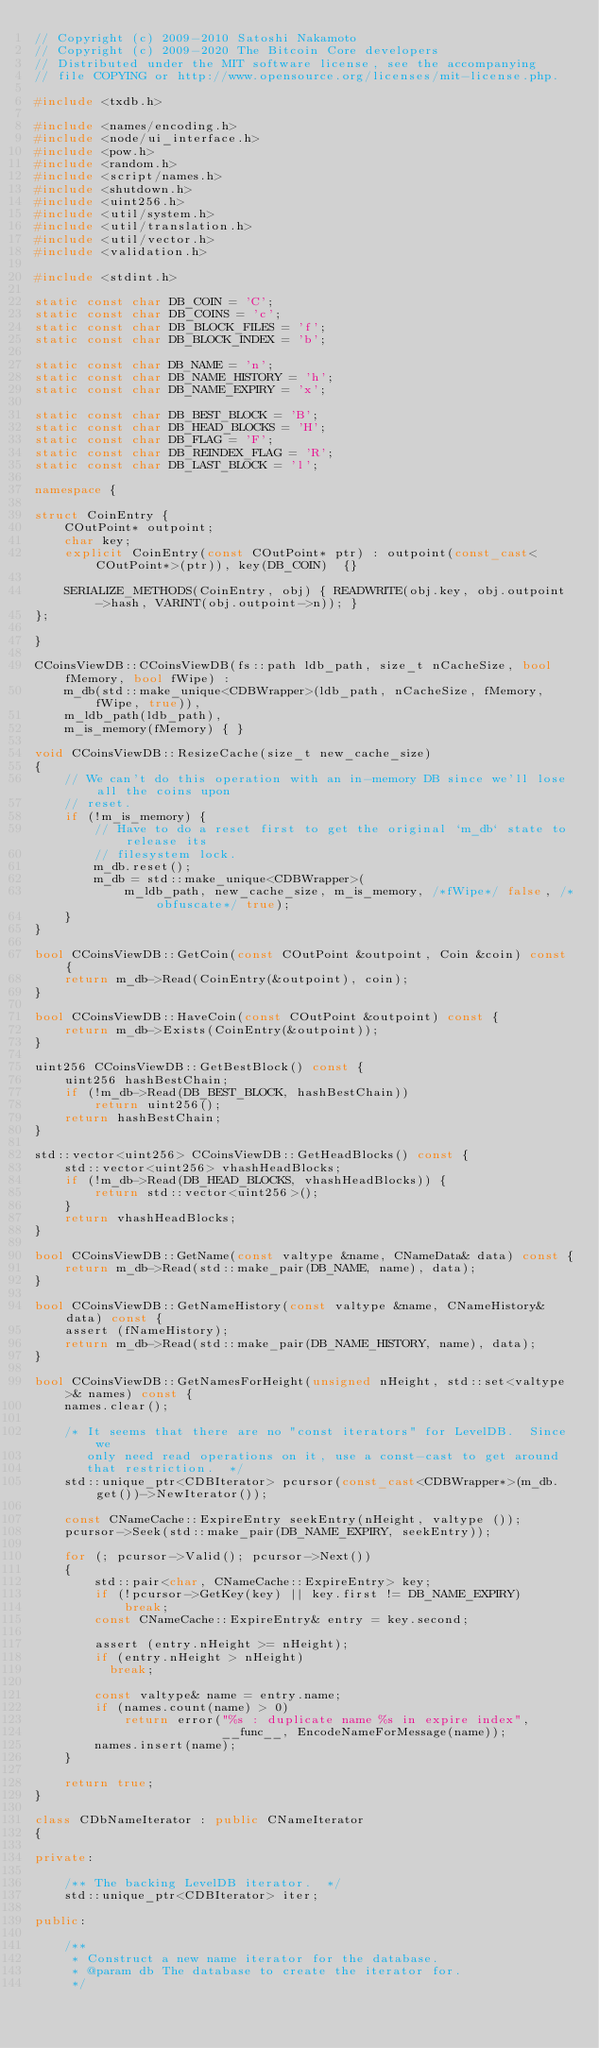Convert code to text. <code><loc_0><loc_0><loc_500><loc_500><_C++_>// Copyright (c) 2009-2010 Satoshi Nakamoto
// Copyright (c) 2009-2020 The Bitcoin Core developers
// Distributed under the MIT software license, see the accompanying
// file COPYING or http://www.opensource.org/licenses/mit-license.php.

#include <txdb.h>

#include <names/encoding.h>
#include <node/ui_interface.h>
#include <pow.h>
#include <random.h>
#include <script/names.h>
#include <shutdown.h>
#include <uint256.h>
#include <util/system.h>
#include <util/translation.h>
#include <util/vector.h>
#include <validation.h>

#include <stdint.h>

static const char DB_COIN = 'C';
static const char DB_COINS = 'c';
static const char DB_BLOCK_FILES = 'f';
static const char DB_BLOCK_INDEX = 'b';

static const char DB_NAME = 'n';
static const char DB_NAME_HISTORY = 'h';
static const char DB_NAME_EXPIRY = 'x';

static const char DB_BEST_BLOCK = 'B';
static const char DB_HEAD_BLOCKS = 'H';
static const char DB_FLAG = 'F';
static const char DB_REINDEX_FLAG = 'R';
static const char DB_LAST_BLOCK = 'l';

namespace {

struct CoinEntry {
    COutPoint* outpoint;
    char key;
    explicit CoinEntry(const COutPoint* ptr) : outpoint(const_cast<COutPoint*>(ptr)), key(DB_COIN)  {}

    SERIALIZE_METHODS(CoinEntry, obj) { READWRITE(obj.key, obj.outpoint->hash, VARINT(obj.outpoint->n)); }
};

}

CCoinsViewDB::CCoinsViewDB(fs::path ldb_path, size_t nCacheSize, bool fMemory, bool fWipe) :
    m_db(std::make_unique<CDBWrapper>(ldb_path, nCacheSize, fMemory, fWipe, true)),
    m_ldb_path(ldb_path),
    m_is_memory(fMemory) { }

void CCoinsViewDB::ResizeCache(size_t new_cache_size)
{
    // We can't do this operation with an in-memory DB since we'll lose all the coins upon
    // reset.
    if (!m_is_memory) {
        // Have to do a reset first to get the original `m_db` state to release its
        // filesystem lock.
        m_db.reset();
        m_db = std::make_unique<CDBWrapper>(
            m_ldb_path, new_cache_size, m_is_memory, /*fWipe*/ false, /*obfuscate*/ true);
    }
}

bool CCoinsViewDB::GetCoin(const COutPoint &outpoint, Coin &coin) const {
    return m_db->Read(CoinEntry(&outpoint), coin);
}

bool CCoinsViewDB::HaveCoin(const COutPoint &outpoint) const {
    return m_db->Exists(CoinEntry(&outpoint));
}

uint256 CCoinsViewDB::GetBestBlock() const {
    uint256 hashBestChain;
    if (!m_db->Read(DB_BEST_BLOCK, hashBestChain))
        return uint256();
    return hashBestChain;
}

std::vector<uint256> CCoinsViewDB::GetHeadBlocks() const {
    std::vector<uint256> vhashHeadBlocks;
    if (!m_db->Read(DB_HEAD_BLOCKS, vhashHeadBlocks)) {
        return std::vector<uint256>();
    }
    return vhashHeadBlocks;
}

bool CCoinsViewDB::GetName(const valtype &name, CNameData& data) const {
    return m_db->Read(std::make_pair(DB_NAME, name), data);
}

bool CCoinsViewDB::GetNameHistory(const valtype &name, CNameHistory& data) const {
    assert (fNameHistory);
    return m_db->Read(std::make_pair(DB_NAME_HISTORY, name), data);
}

bool CCoinsViewDB::GetNamesForHeight(unsigned nHeight, std::set<valtype>& names) const {
    names.clear();

    /* It seems that there are no "const iterators" for LevelDB.  Since we
       only need read operations on it, use a const-cast to get around
       that restriction.  */
    std::unique_ptr<CDBIterator> pcursor(const_cast<CDBWrapper*>(m_db.get())->NewIterator());

    const CNameCache::ExpireEntry seekEntry(nHeight, valtype ());
    pcursor->Seek(std::make_pair(DB_NAME_EXPIRY, seekEntry));

    for (; pcursor->Valid(); pcursor->Next())
    {
        std::pair<char, CNameCache::ExpireEntry> key;
        if (!pcursor->GetKey(key) || key.first != DB_NAME_EXPIRY)
            break;
        const CNameCache::ExpireEntry& entry = key.second;

        assert (entry.nHeight >= nHeight);
        if (entry.nHeight > nHeight)
          break;

        const valtype& name = entry.name;
        if (names.count(name) > 0)
            return error("%s : duplicate name %s in expire index",
                         __func__, EncodeNameForMessage(name));
        names.insert(name);
    }

    return true;
}

class CDbNameIterator : public CNameIterator
{

private:

    /** The backing LevelDB iterator.  */
    std::unique_ptr<CDBIterator> iter;

public:

    /**
     * Construct a new name iterator for the database.
     * @param db The database to create the iterator for.
     */</code> 